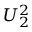Convert formula to latex. <formula><loc_0><loc_0><loc_500><loc_500>U _ { 2 } ^ { 2 }</formula> 